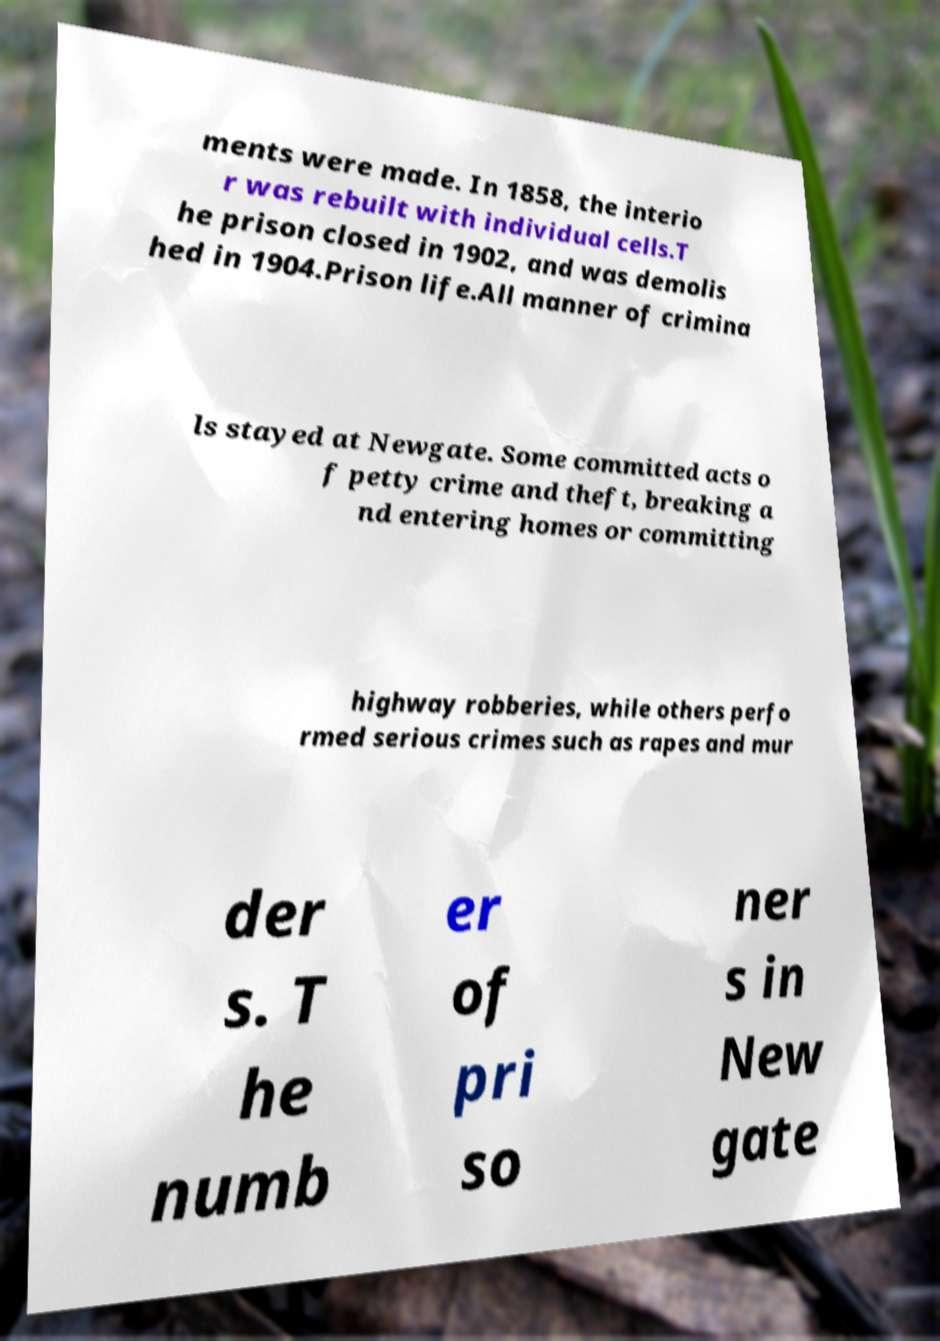What messages or text are displayed in this image? I need them in a readable, typed format. ments were made. In 1858, the interio r was rebuilt with individual cells.T he prison closed in 1902, and was demolis hed in 1904.Prison life.All manner of crimina ls stayed at Newgate. Some committed acts o f petty crime and theft, breaking a nd entering homes or committing highway robberies, while others perfo rmed serious crimes such as rapes and mur der s. T he numb er of pri so ner s in New gate 